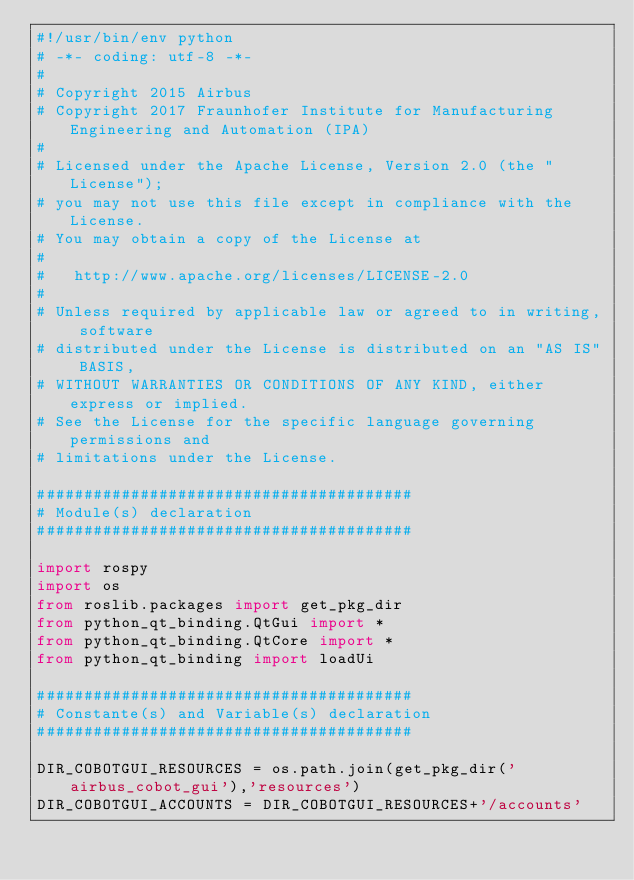<code> <loc_0><loc_0><loc_500><loc_500><_Python_>#!/usr/bin/env python
# -*- coding: utf-8 -*-
#
# Copyright 2015 Airbus
# Copyright 2017 Fraunhofer Institute for Manufacturing Engineering and Automation (IPA)
#
# Licensed under the Apache License, Version 2.0 (the "License");
# you may not use this file except in compliance with the License.
# You may obtain a copy of the License at
#
#   http://www.apache.org/licenses/LICENSE-2.0
#
# Unless required by applicable law or agreed to in writing, software
# distributed under the License is distributed on an "AS IS" BASIS,
# WITHOUT WARRANTIES OR CONDITIONS OF ANY KIND, either express or implied.
# See the License for the specific language governing permissions and
# limitations under the License.

########################################
# Module(s) declaration
########################################

import rospy
import os
from roslib.packages import get_pkg_dir
from python_qt_binding.QtGui import *
from python_qt_binding.QtCore import *
from python_qt_binding import loadUi

########################################
# Constante(s) and Variable(s) declaration
########################################

DIR_COBOTGUI_RESOURCES = os.path.join(get_pkg_dir('airbus_cobot_gui'),'resources')
DIR_COBOTGUI_ACCOUNTS = DIR_COBOTGUI_RESOURCES+'/accounts'</code> 